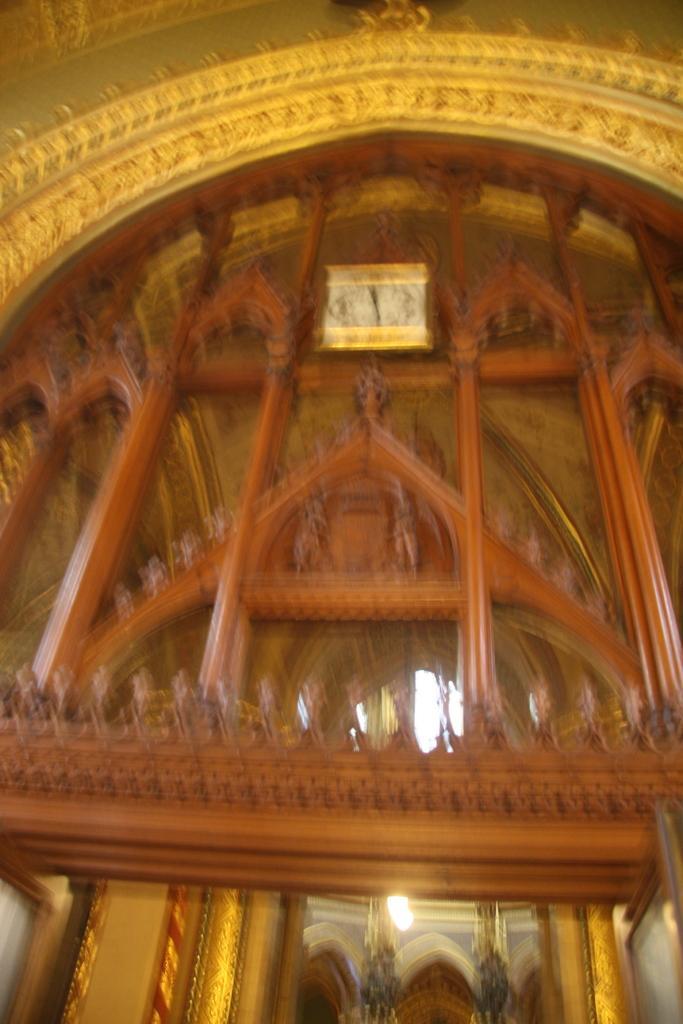How would you summarize this image in a sentence or two? In this image we can see inside of a building. There are few lamps in the image. There is a clock in the image. 